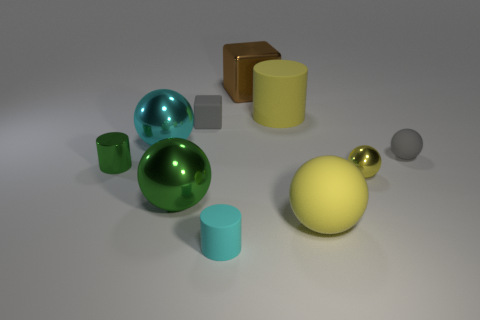How many objects are tiny metal objects or large spheres that are on the right side of the cyan rubber cylinder?
Give a very brief answer. 3. What is the color of the small rubber block?
Ensure brevity in your answer.  Gray. What material is the gray object that is on the left side of the big metal object that is on the right side of the block in front of the large cylinder?
Give a very brief answer. Rubber. The cyan cylinder that is the same material as the yellow cylinder is what size?
Keep it short and to the point. Small. Is there a large matte ball that has the same color as the shiny cylinder?
Keep it short and to the point. No. There is a gray sphere; is it the same size as the yellow matte object in front of the tiny green metallic cylinder?
Offer a very short reply. No. There is a rubber ball that is in front of the small shiny object to the left of the brown metallic thing; what number of small green metal things are behind it?
Keep it short and to the point. 1. What is the size of the rubber thing that is the same color as the big rubber ball?
Ensure brevity in your answer.  Large. There is a cyan matte object; are there any cubes right of it?
Provide a short and direct response. Yes. What is the shape of the brown metallic object?
Give a very brief answer. Cube. 